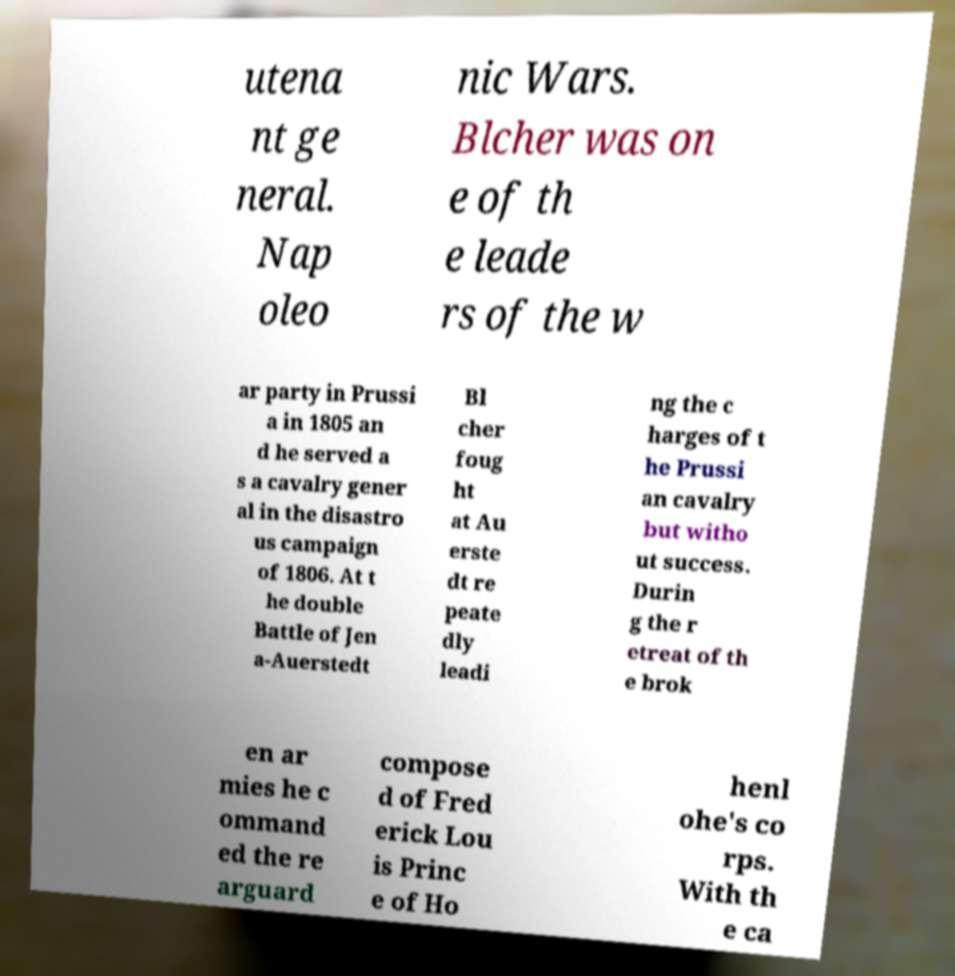Can you read and provide the text displayed in the image?This photo seems to have some interesting text. Can you extract and type it out for me? utena nt ge neral. Nap oleo nic Wars. Blcher was on e of th e leade rs of the w ar party in Prussi a in 1805 an d he served a s a cavalry gener al in the disastro us campaign of 1806. At t he double Battle of Jen a-Auerstedt Bl cher foug ht at Au erste dt re peate dly leadi ng the c harges of t he Prussi an cavalry but witho ut success. Durin g the r etreat of th e brok en ar mies he c ommand ed the re arguard compose d of Fred erick Lou is Princ e of Ho henl ohe's co rps. With th e ca 